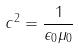<formula> <loc_0><loc_0><loc_500><loc_500>c ^ { 2 } = \frac { 1 } { \epsilon _ { 0 } \mu _ { 0 } }</formula> 